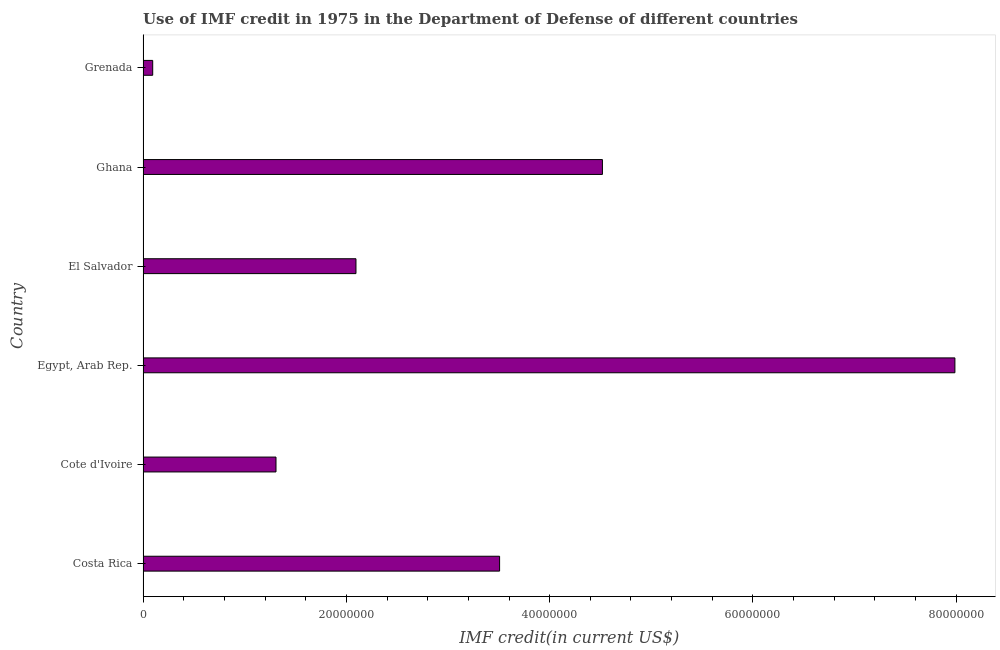Does the graph contain any zero values?
Provide a short and direct response. No. What is the title of the graph?
Your answer should be very brief. Use of IMF credit in 1975 in the Department of Defense of different countries. What is the label or title of the X-axis?
Give a very brief answer. IMF credit(in current US$). What is the use of imf credit in dod in Costa Rica?
Make the answer very short. 3.51e+07. Across all countries, what is the maximum use of imf credit in dod?
Give a very brief answer. 7.99e+07. Across all countries, what is the minimum use of imf credit in dod?
Give a very brief answer. 9.48e+05. In which country was the use of imf credit in dod maximum?
Your answer should be compact. Egypt, Arab Rep. In which country was the use of imf credit in dod minimum?
Ensure brevity in your answer.  Grenada. What is the sum of the use of imf credit in dod?
Provide a short and direct response. 1.95e+08. What is the difference between the use of imf credit in dod in Cote d'Ivoire and Grenada?
Provide a succinct answer. 1.21e+07. What is the average use of imf credit in dod per country?
Your answer should be very brief. 3.25e+07. What is the median use of imf credit in dod?
Ensure brevity in your answer.  2.80e+07. In how many countries, is the use of imf credit in dod greater than 24000000 US$?
Give a very brief answer. 3. What is the ratio of the use of imf credit in dod in Egypt, Arab Rep. to that in El Salvador?
Offer a terse response. 3.81. Is the use of imf credit in dod in Egypt, Arab Rep. less than that in Grenada?
Ensure brevity in your answer.  No. Is the difference between the use of imf credit in dod in Cote d'Ivoire and Egypt, Arab Rep. greater than the difference between any two countries?
Your response must be concise. No. What is the difference between the highest and the second highest use of imf credit in dod?
Provide a succinct answer. 3.47e+07. Is the sum of the use of imf credit in dod in El Salvador and Grenada greater than the maximum use of imf credit in dod across all countries?
Offer a very short reply. No. What is the difference between the highest and the lowest use of imf credit in dod?
Offer a very short reply. 7.89e+07. In how many countries, is the use of imf credit in dod greater than the average use of imf credit in dod taken over all countries?
Provide a succinct answer. 3. How many bars are there?
Offer a very short reply. 6. Are all the bars in the graph horizontal?
Your response must be concise. Yes. What is the difference between two consecutive major ticks on the X-axis?
Give a very brief answer. 2.00e+07. What is the IMF credit(in current US$) of Costa Rica?
Give a very brief answer. 3.51e+07. What is the IMF credit(in current US$) of Cote d'Ivoire?
Ensure brevity in your answer.  1.31e+07. What is the IMF credit(in current US$) in Egypt, Arab Rep.?
Provide a short and direct response. 7.99e+07. What is the IMF credit(in current US$) of El Salvador?
Make the answer very short. 2.09e+07. What is the IMF credit(in current US$) in Ghana?
Your answer should be very brief. 4.52e+07. What is the IMF credit(in current US$) in Grenada?
Provide a short and direct response. 9.48e+05. What is the difference between the IMF credit(in current US$) in Costa Rica and Cote d'Ivoire?
Ensure brevity in your answer.  2.20e+07. What is the difference between the IMF credit(in current US$) in Costa Rica and Egypt, Arab Rep.?
Provide a short and direct response. -4.48e+07. What is the difference between the IMF credit(in current US$) in Costa Rica and El Salvador?
Your response must be concise. 1.41e+07. What is the difference between the IMF credit(in current US$) in Costa Rica and Ghana?
Give a very brief answer. -1.01e+07. What is the difference between the IMF credit(in current US$) in Costa Rica and Grenada?
Offer a very short reply. 3.41e+07. What is the difference between the IMF credit(in current US$) in Cote d'Ivoire and Egypt, Arab Rep.?
Your answer should be very brief. -6.68e+07. What is the difference between the IMF credit(in current US$) in Cote d'Ivoire and El Salvador?
Ensure brevity in your answer.  -7.87e+06. What is the difference between the IMF credit(in current US$) in Cote d'Ivoire and Ghana?
Ensure brevity in your answer.  -3.21e+07. What is the difference between the IMF credit(in current US$) in Cote d'Ivoire and Grenada?
Make the answer very short. 1.21e+07. What is the difference between the IMF credit(in current US$) in Egypt, Arab Rep. and El Salvador?
Offer a very short reply. 5.89e+07. What is the difference between the IMF credit(in current US$) in Egypt, Arab Rep. and Ghana?
Offer a very short reply. 3.47e+07. What is the difference between the IMF credit(in current US$) in Egypt, Arab Rep. and Grenada?
Your answer should be very brief. 7.89e+07. What is the difference between the IMF credit(in current US$) in El Salvador and Ghana?
Your response must be concise. -2.42e+07. What is the difference between the IMF credit(in current US$) in El Salvador and Grenada?
Offer a very short reply. 2.00e+07. What is the difference between the IMF credit(in current US$) in Ghana and Grenada?
Make the answer very short. 4.42e+07. What is the ratio of the IMF credit(in current US$) in Costa Rica to that in Cote d'Ivoire?
Keep it short and to the point. 2.68. What is the ratio of the IMF credit(in current US$) in Costa Rica to that in Egypt, Arab Rep.?
Your answer should be very brief. 0.44. What is the ratio of the IMF credit(in current US$) in Costa Rica to that in El Salvador?
Make the answer very short. 1.68. What is the ratio of the IMF credit(in current US$) in Costa Rica to that in Ghana?
Your answer should be compact. 0.78. What is the ratio of the IMF credit(in current US$) in Costa Rica to that in Grenada?
Offer a very short reply. 37. What is the ratio of the IMF credit(in current US$) in Cote d'Ivoire to that in Egypt, Arab Rep.?
Offer a terse response. 0.16. What is the ratio of the IMF credit(in current US$) in Cote d'Ivoire to that in El Salvador?
Provide a succinct answer. 0.62. What is the ratio of the IMF credit(in current US$) in Cote d'Ivoire to that in Ghana?
Your response must be concise. 0.29. What is the ratio of the IMF credit(in current US$) in Cote d'Ivoire to that in Grenada?
Give a very brief answer. 13.79. What is the ratio of the IMF credit(in current US$) in Egypt, Arab Rep. to that in El Salvador?
Make the answer very short. 3.81. What is the ratio of the IMF credit(in current US$) in Egypt, Arab Rep. to that in Ghana?
Your answer should be very brief. 1.77. What is the ratio of the IMF credit(in current US$) in Egypt, Arab Rep. to that in Grenada?
Provide a succinct answer. 84.25. What is the ratio of the IMF credit(in current US$) in El Salvador to that in Ghana?
Ensure brevity in your answer.  0.46. What is the ratio of the IMF credit(in current US$) in El Salvador to that in Grenada?
Keep it short and to the point. 22.09. What is the ratio of the IMF credit(in current US$) in Ghana to that in Grenada?
Provide a short and direct response. 47.67. 